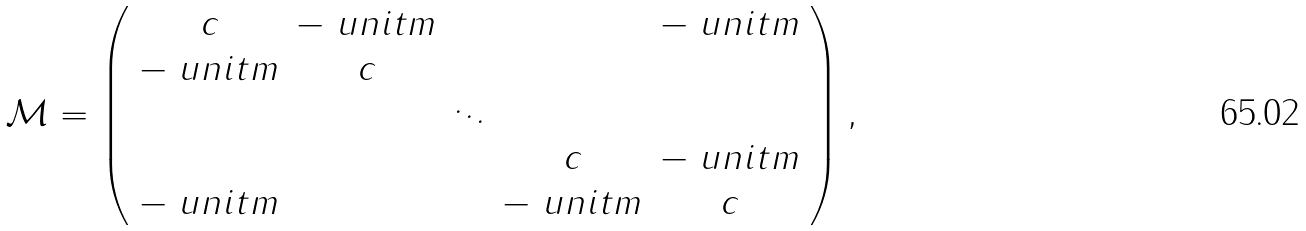Convert formula to latex. <formula><loc_0><loc_0><loc_500><loc_500>\mathcal { M } = \left ( \begin{array} { c c c c c } c & - \ u n i t m & & & - \ u n i t m \\ - \ u n i t m & c & & & \\ & & \ddots & & \\ & & & c & - \ u n i t m \\ - \ u n i t m & & & - \ u n i t m & c \end{array} \right ) ,</formula> 